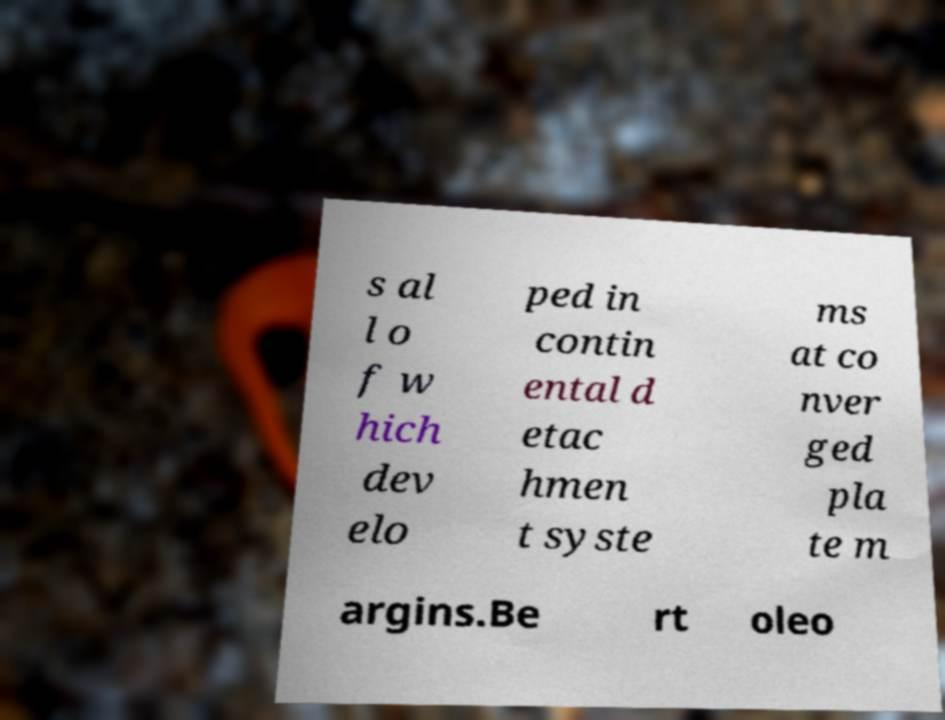What messages or text are displayed in this image? I need them in a readable, typed format. s al l o f w hich dev elo ped in contin ental d etac hmen t syste ms at co nver ged pla te m argins.Be rt oleo 